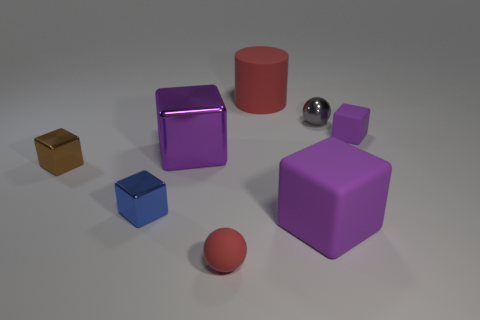Subtract all tiny brown cubes. How many cubes are left? 4 Add 1 large red things. How many objects exist? 9 Subtract all blocks. How many objects are left? 3 Subtract all purple cubes. How many cubes are left? 2 Subtract 1 cylinders. How many cylinders are left? 0 Add 6 tiny red balls. How many tiny red balls exist? 7 Subtract 0 cyan blocks. How many objects are left? 8 Subtract all gray balls. Subtract all purple cylinders. How many balls are left? 1 Subtract all cyan cubes. How many brown spheres are left? 0 Subtract all small gray matte blocks. Subtract all big metal things. How many objects are left? 7 